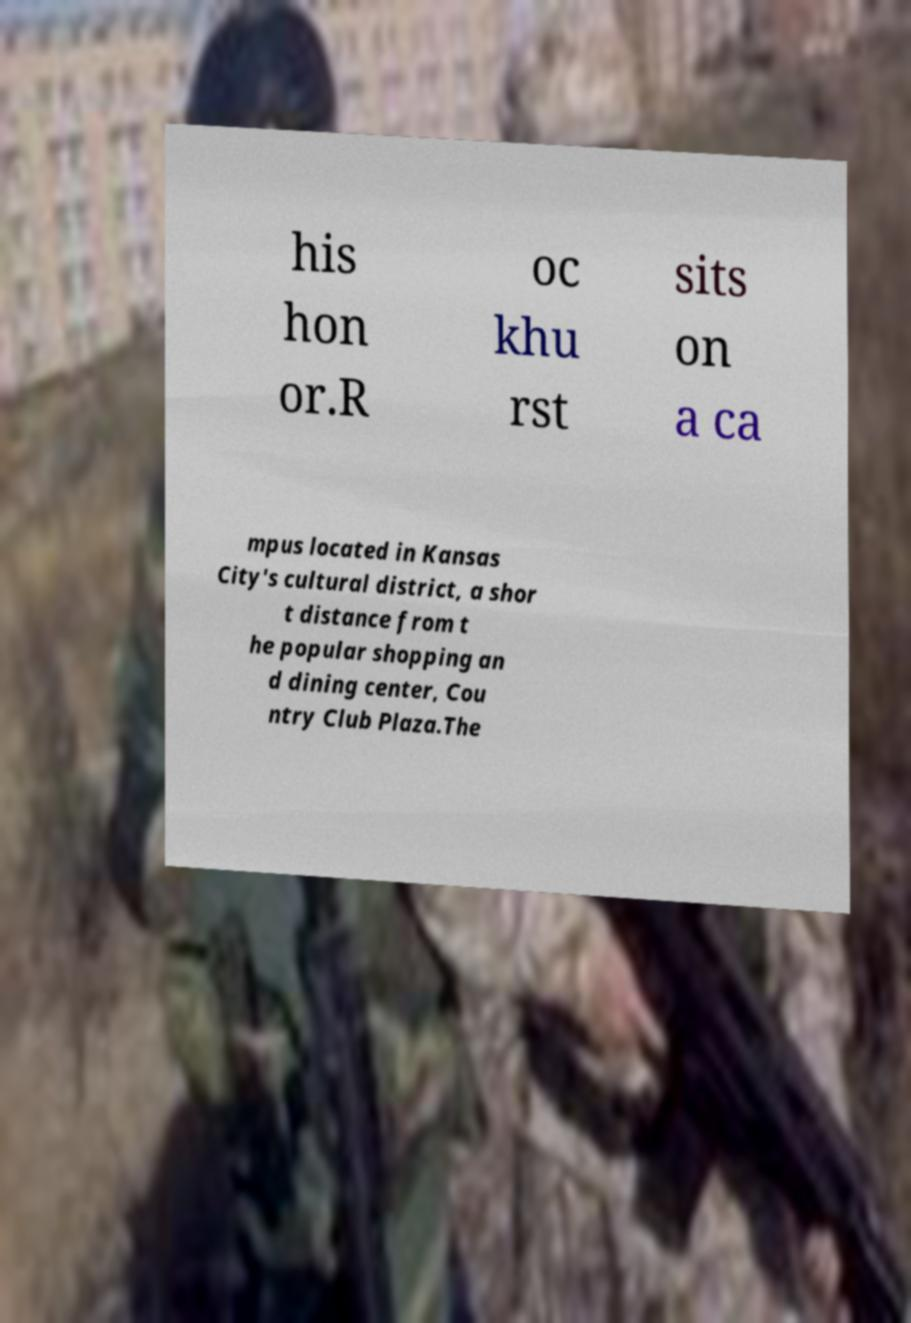Can you accurately transcribe the text from the provided image for me? his hon or.R oc khu rst sits on a ca mpus located in Kansas City's cultural district, a shor t distance from t he popular shopping an d dining center, Cou ntry Club Plaza.The 